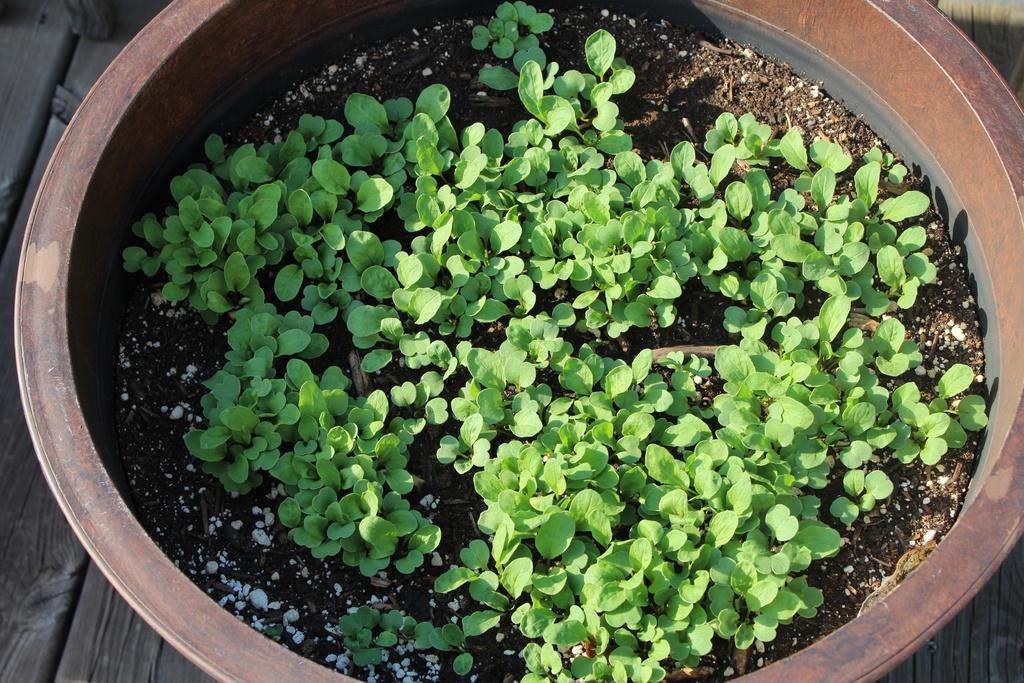Please provide a concise description of this image. In this picture we can see there are plants and soil in the pot, and the pot is on the wooden object. 